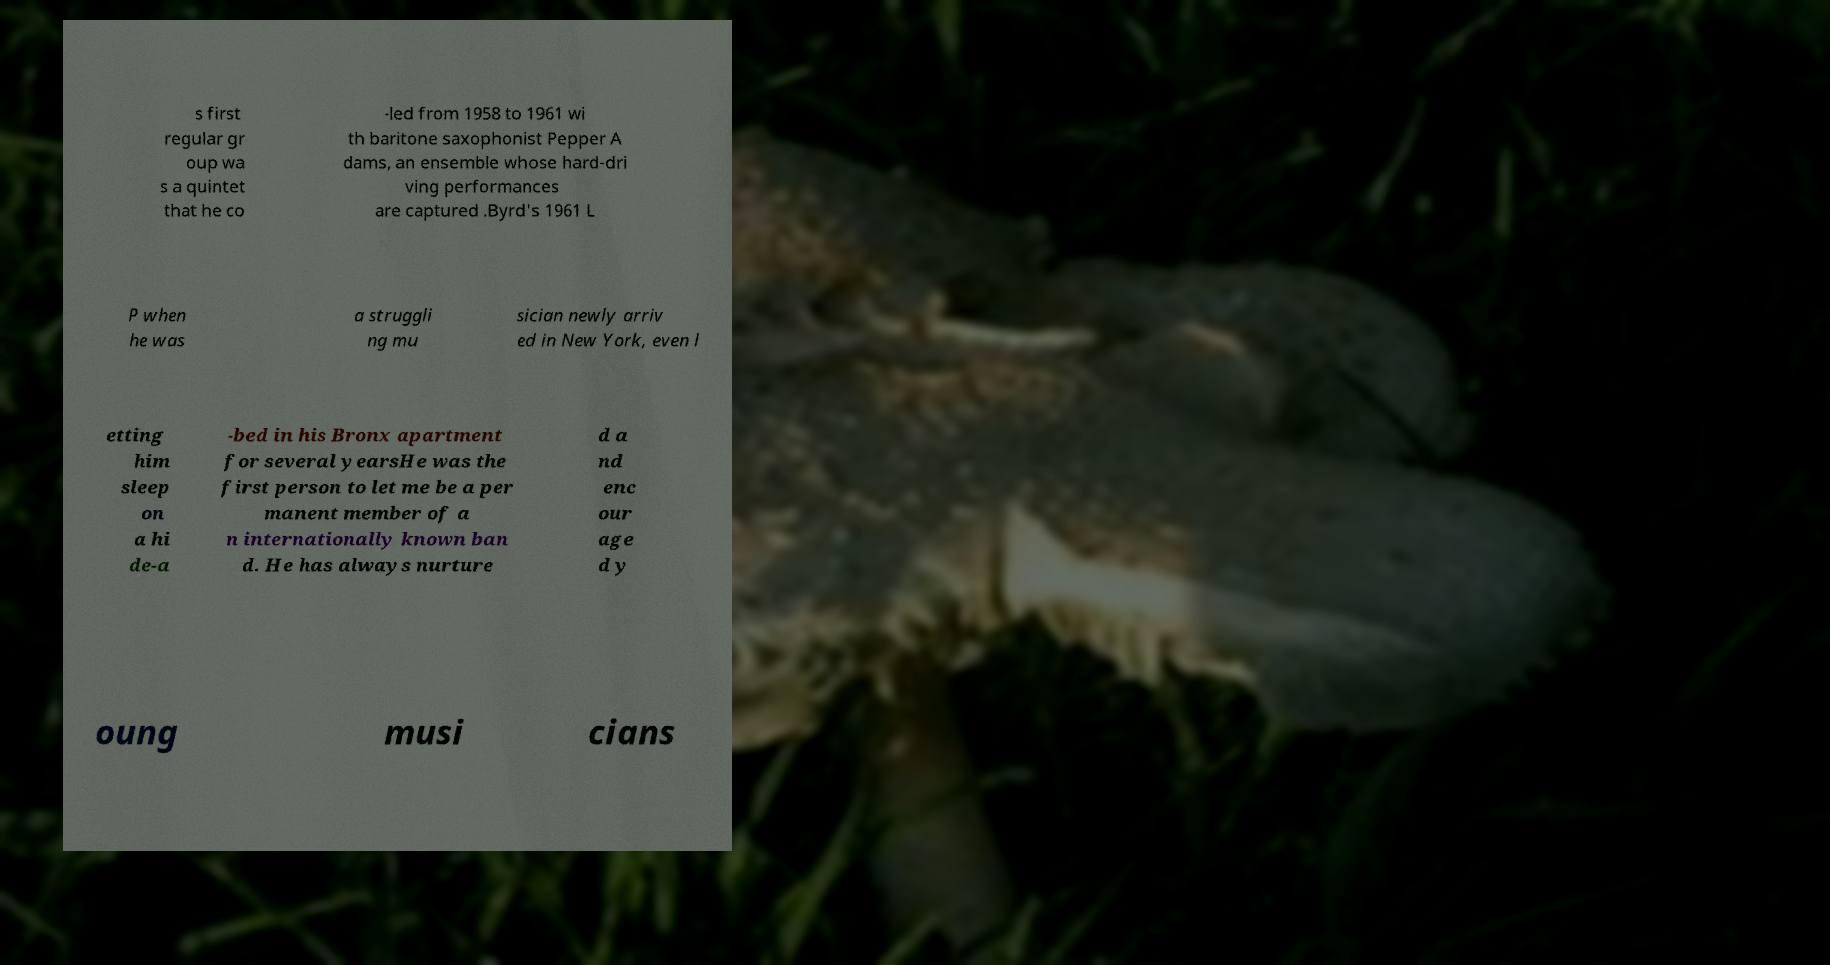What messages or text are displayed in this image? I need them in a readable, typed format. s first regular gr oup wa s a quintet that he co -led from 1958 to 1961 wi th baritone saxophonist Pepper A dams, an ensemble whose hard-dri ving performances are captured .Byrd's 1961 L P when he was a struggli ng mu sician newly arriv ed in New York, even l etting him sleep on a hi de-a -bed in his Bronx apartment for several yearsHe was the first person to let me be a per manent member of a n internationally known ban d. He has always nurture d a nd enc our age d y oung musi cians 